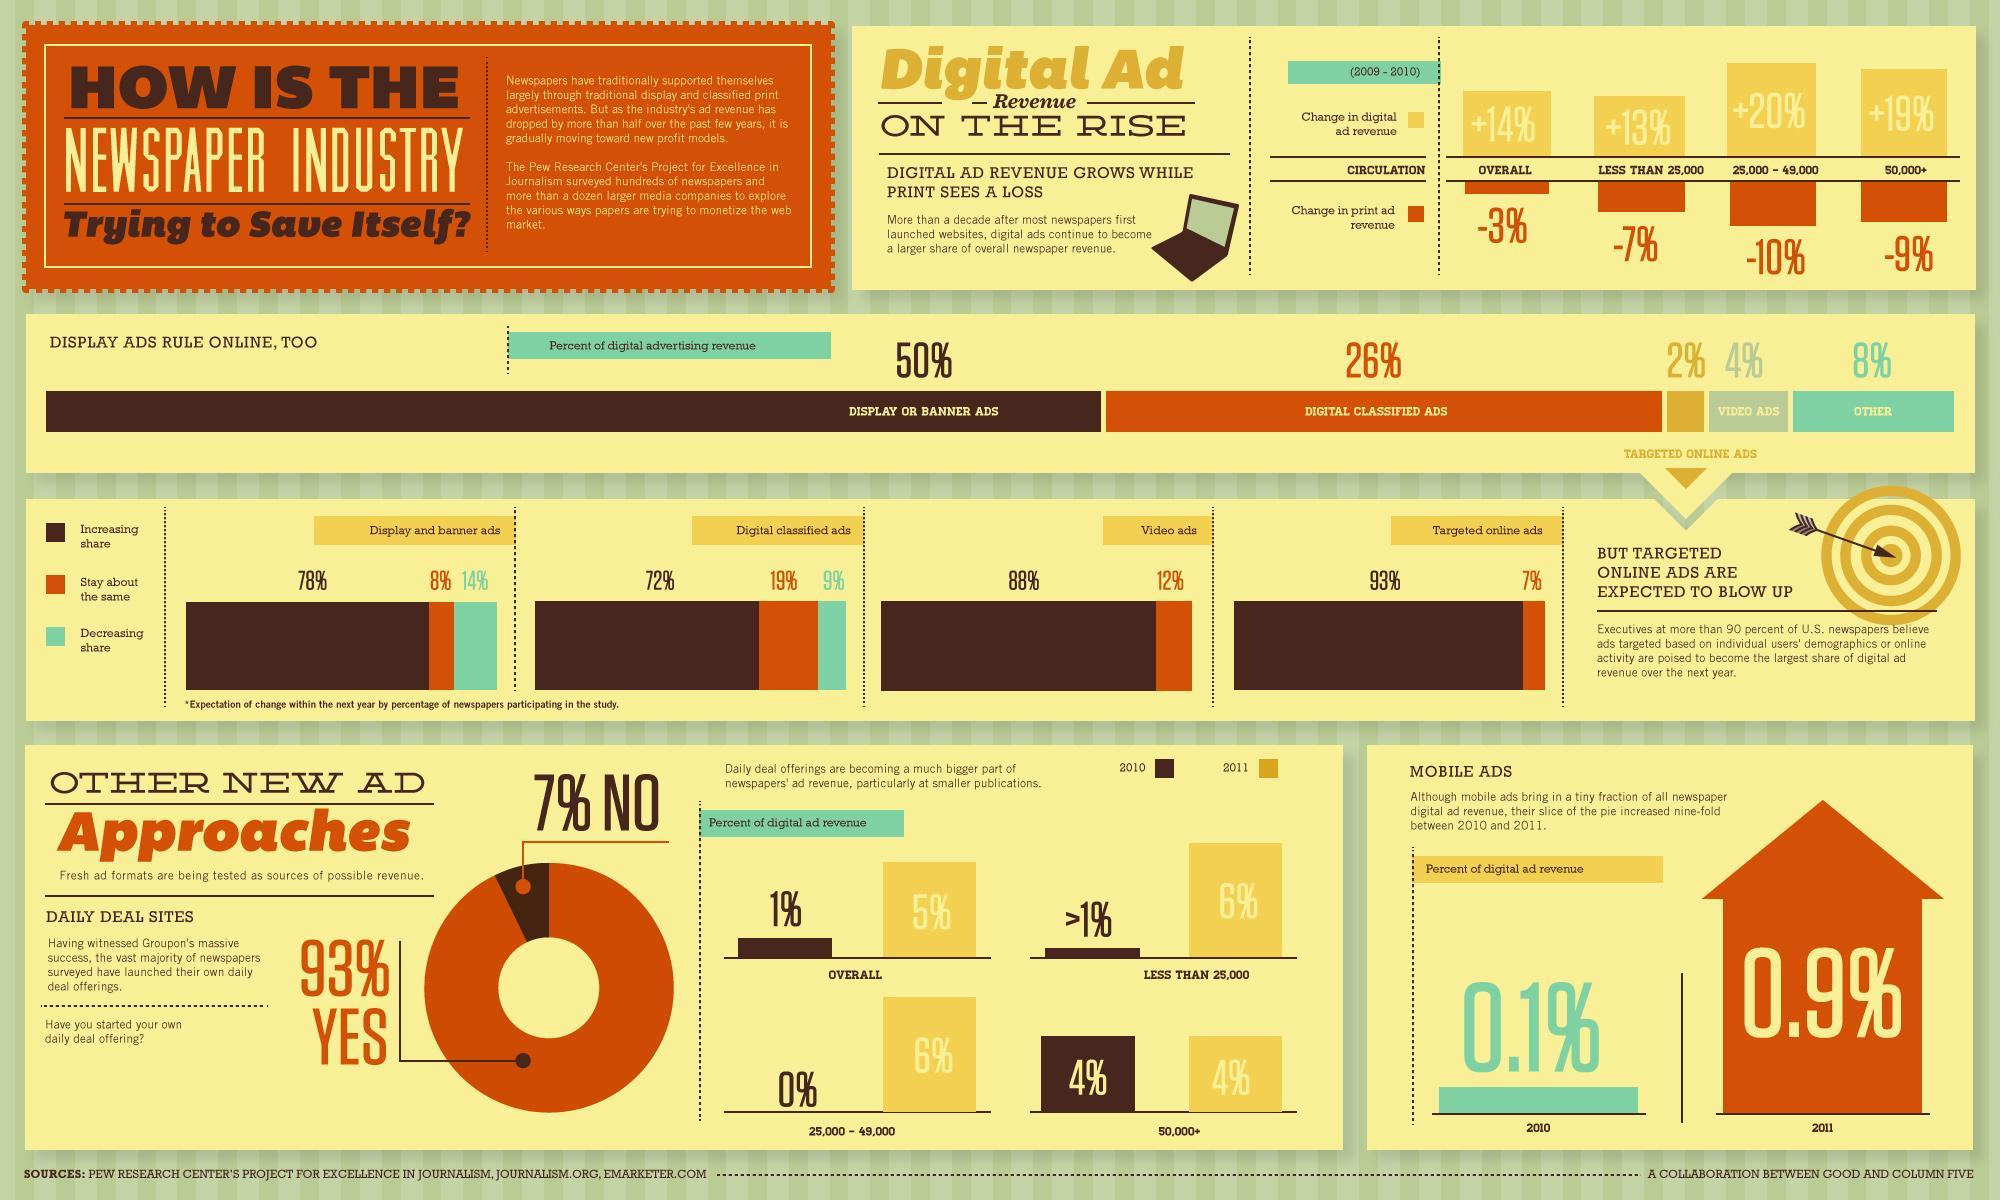What percentage increase is expected in the share of display & banner ads within the next year according to the study?
Answer the question with a short phrase. 78% What percentage decrease is expected in the share of digital classified ads within the next year according to the study? 9% What is the overall change in the digital ad revenue during 2009-2010? +14% What is the overall percent contribution of digital ad revenue in 2010? 1% What is the overall percent contribution of digital ad revenue in online newspapers in 2011? 5% What percentage of revenue is contributed by digital classified Ads in the online newspaper industry? 26% What percent of newspapers agreed that they have started their own daily deal offerings according to the survey? 93% What percentage of revenue is contributed by mobile ads in 2011? 0.9% What percentage of digital advertising revenue is contributed by video ads? 4% Which type of digital advertising contributes to the major part of revenue in the online newspaper industry? DISPLAY ADS 